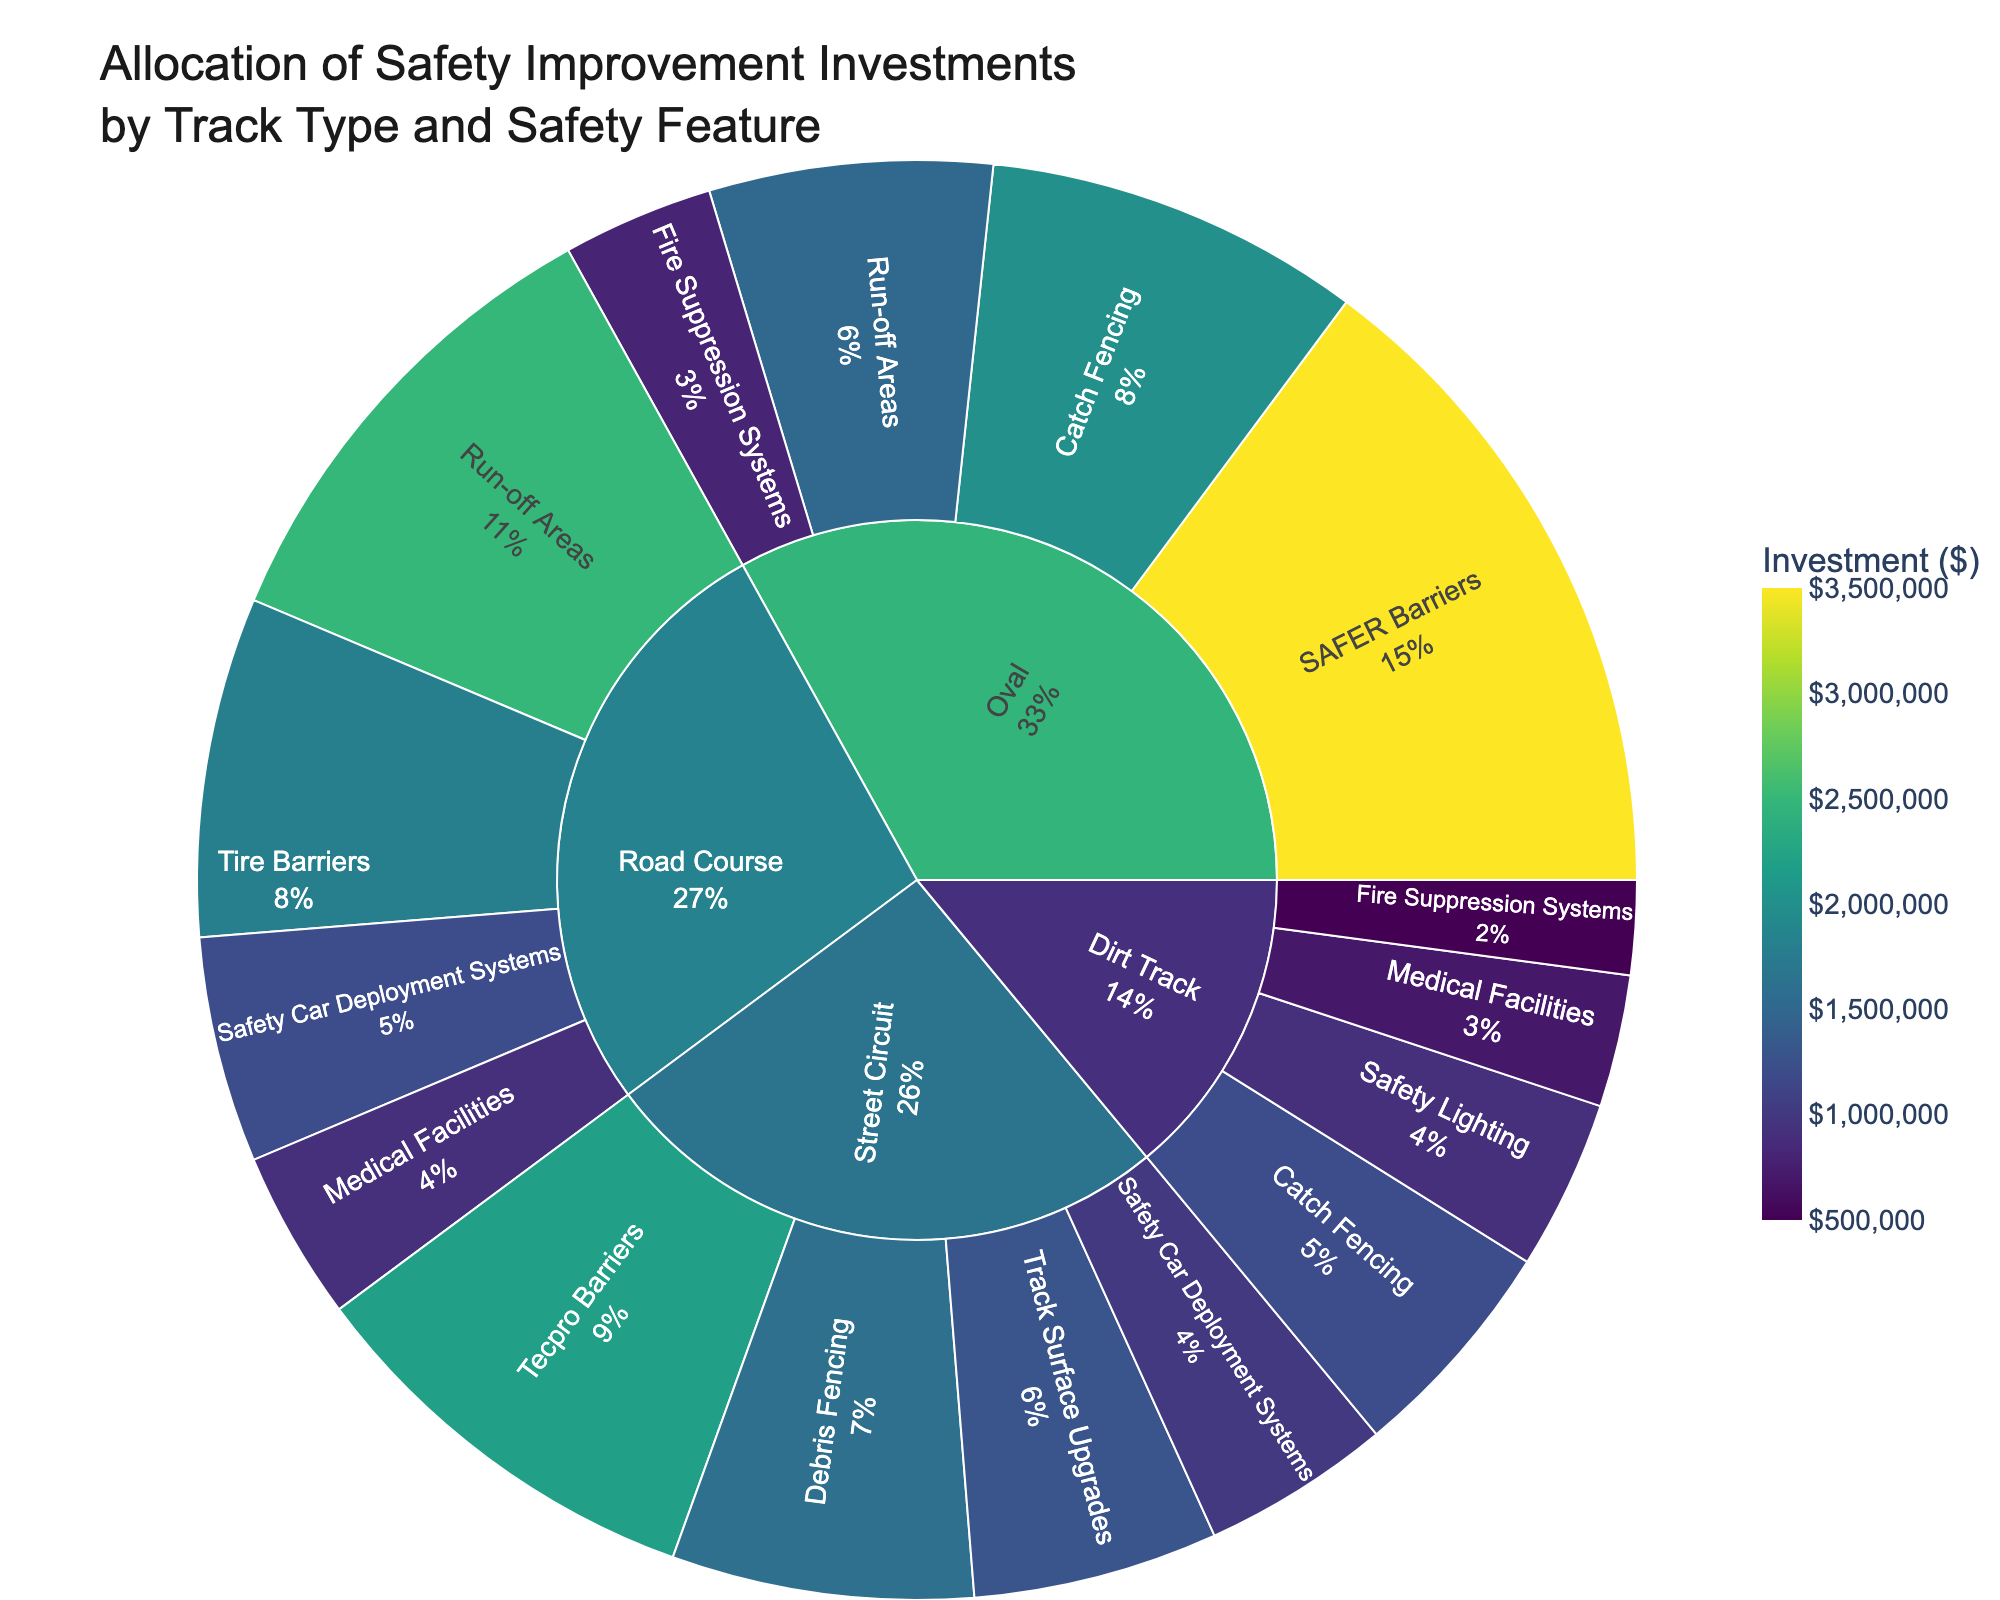What is the total investment in safety improvements for Oval tracks? To find the total investment for Oval tracks, sum the investments for each safety feature under "Oval": \$3,500,000 + \$2,000,000 + \$1,500,000 + \$800,000.
Answer: \$7,800,000 Which track type received the highest total investment? Compare the total investments across all track types: Oval (\$7,800,000), Road Course (\$6,500,000), Street Circuit (\$6,000,000), Dirt Track (\$3,300,000). The highest is the Oval track.
Answer: Oval What percentage of the total investment in Road Course tracks is allocated to Run-off Areas? First, find the total investment in Road Course tracks (\$6,500,000). Then, divide the investment for Run-off Areas (\$2,500,000) by the total and multiply by 100 to get the percentage: (\$2,500,000 / \$6,500,000) * 100.
Answer: 38.46% Which safety feature received the least investment and on which track type? Look for the smallest investment amount: \$500,000 in Fire Suppression Systems on Dirt Track.
Answer: Fire Suppression Systems on Dirt Track How does the investment in Catch Fencing for Oval tracks compare to that for Dirt Tracks? Compare the investment values for Catch Fencing: Oval (\$2,000,000) and Dirt Track (\$1,200,000). Oval investment is greater.
Answer: Oval investment is greater What is the combined investment in Safety Car Deployment Systems across all track types? Sum the investments in Safety Car Deployment Systems for Road Course (\$1,200,000) and Street Circuit (\$1,000,000).
Answer: \$2,200,000 What proportion of the total investment in Street Circuit tracks is allocated to Tecpro Barriers? First, find the total investment in Street Circuit tracks (\$6,000,000). Then, divide the investment for Tecpro Barriers (\$2,200,000) by the total and multiply by 100 to get the percentage: (\$2,200,000 / \$6,000,000) * 100.
Answer: 36.67% What is the average investment amount per safety feature for Dirt Tracks? Sum the investments in Dirt Tracks (\$3,300,000), then divide by the number of safety features (4): \$3,300,000 / 4.
Answer: \$825,000 Which track type has the most diverse allocation of investments across different safety features? Assess the spread of investments across different safety features for each track type. The track type with investments more evenly distributed among its features is Road Course.
Answer: Road Course 